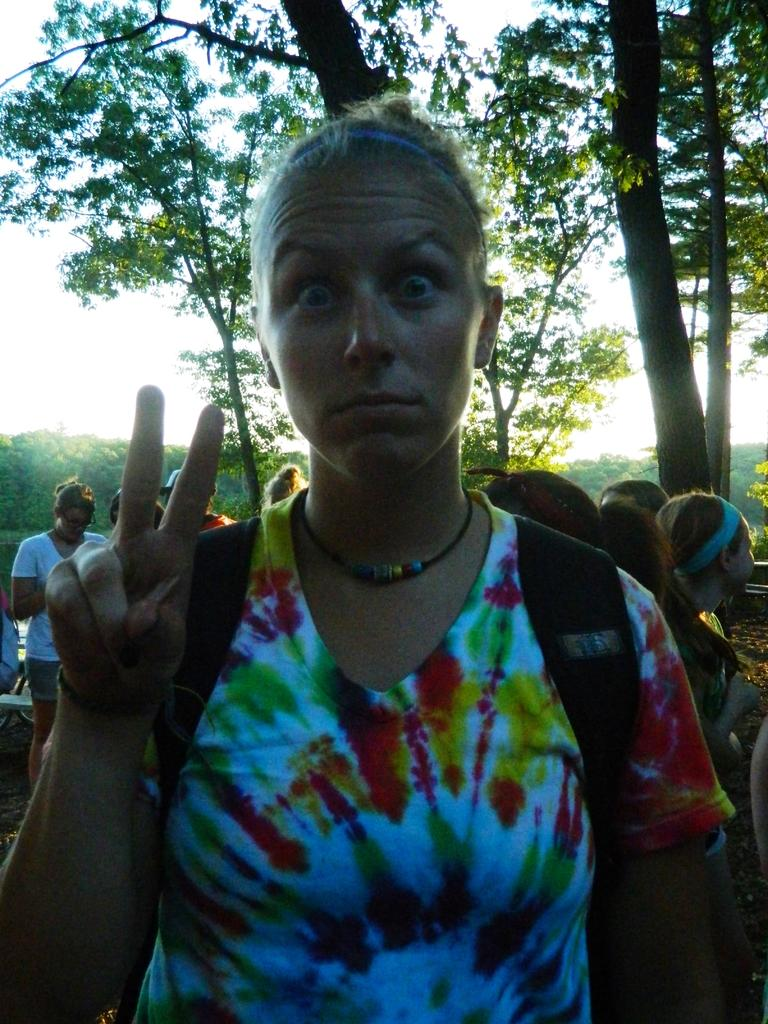Who is the main subject in the image? There is a lady in the image. What is the lady doing in the image? The lady is standing. Can you describe the background of the image? There are many people behind the lady, and there are trees visible in the image. What type of powder is being used by the lady in the image? There is no powder visible in the image, and the lady is not using any powder. How many clocks can be seen in the image? There are no clocks present in the image. 